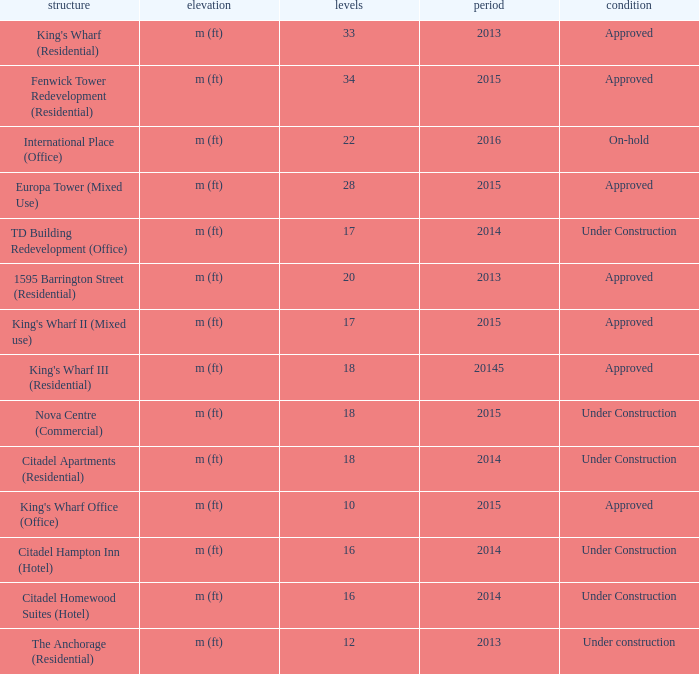What is the status of the building for 2014 with 33 floors? Approved. 